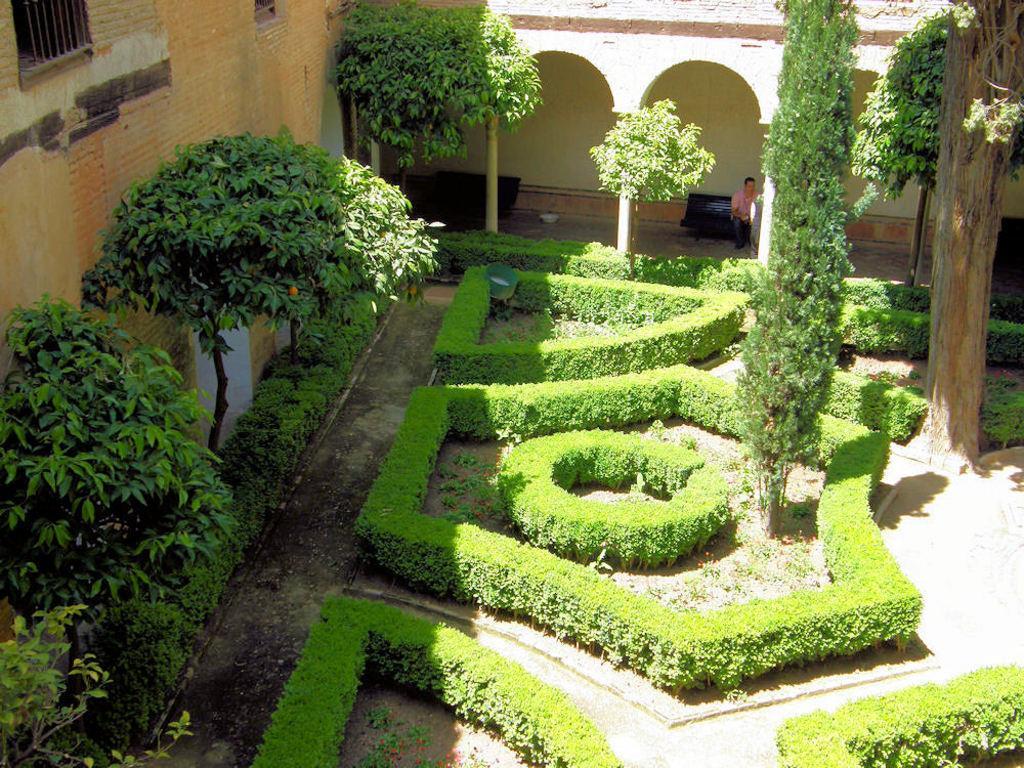In one or two sentences, can you explain what this image depicts? At the bottom of the image there are some plants and trees. Behind the trees there is a building, in the building a man is standing. 